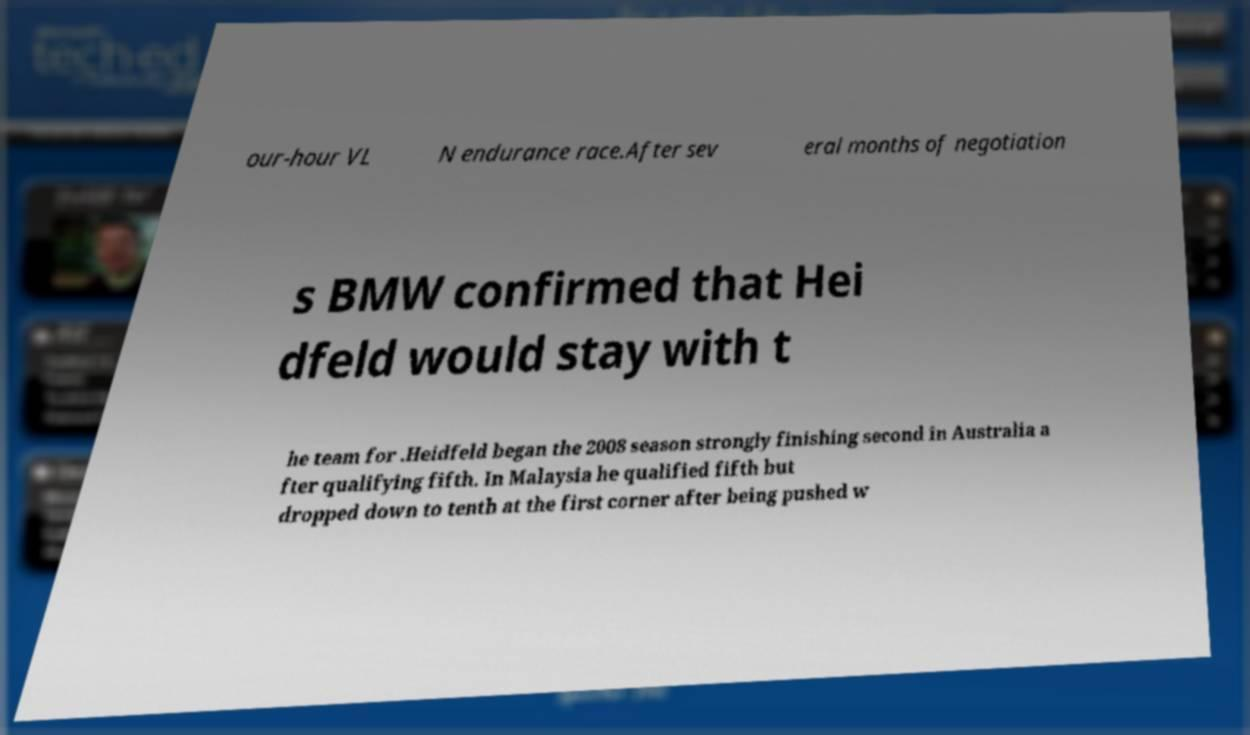For documentation purposes, I need the text within this image transcribed. Could you provide that? our-hour VL N endurance race.After sev eral months of negotiation s BMW confirmed that Hei dfeld would stay with t he team for .Heidfeld began the 2008 season strongly finishing second in Australia a fter qualifying fifth. In Malaysia he qualified fifth but dropped down to tenth at the first corner after being pushed w 